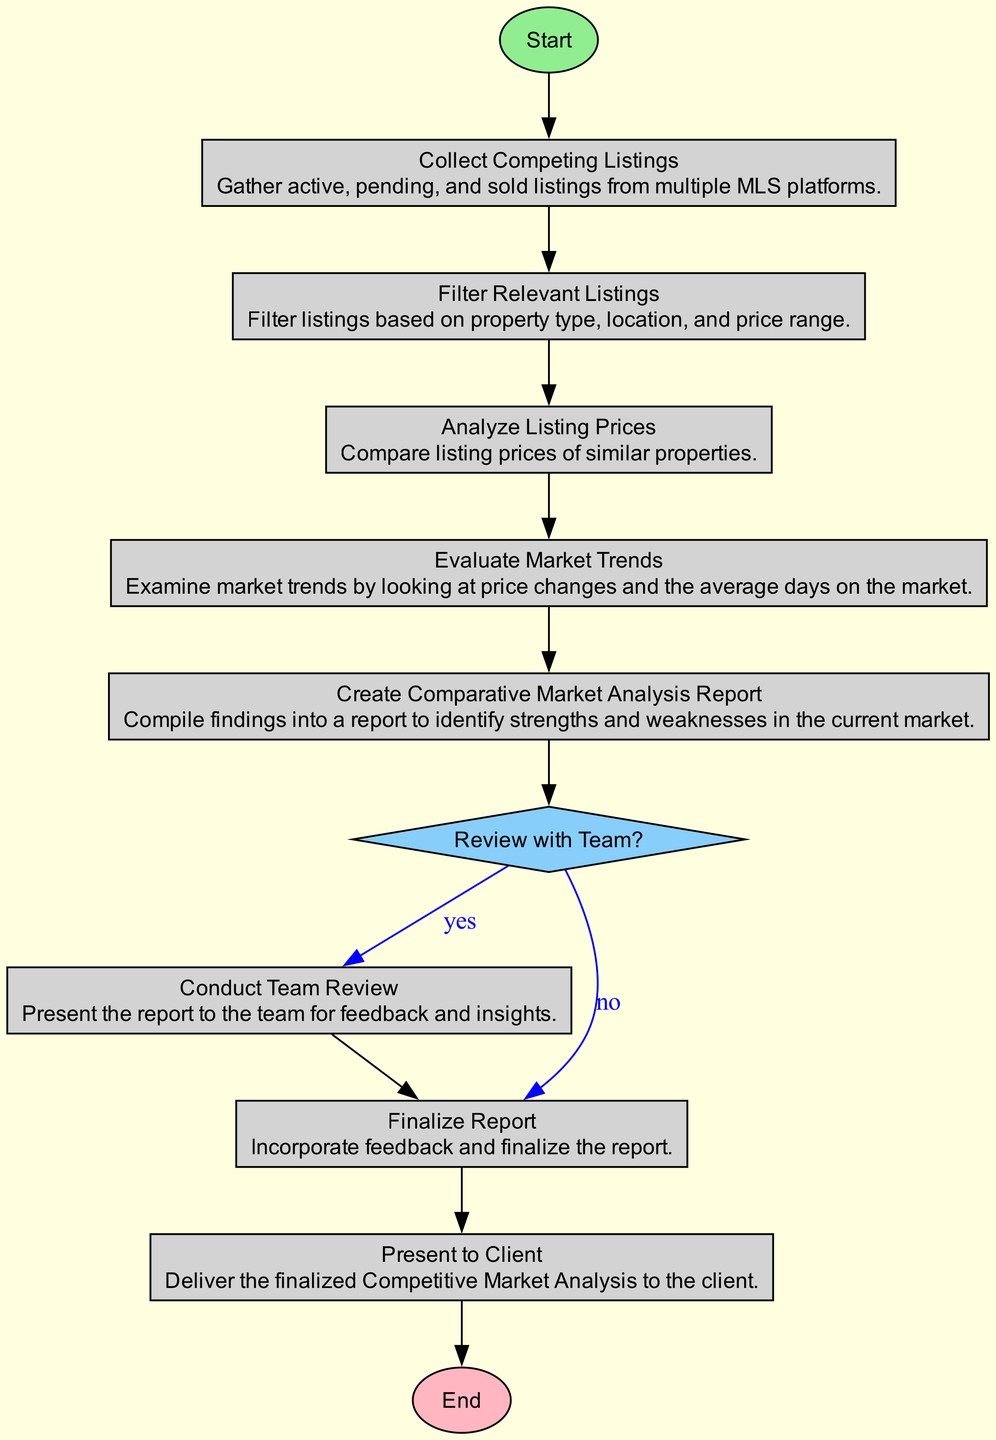What is the first step in the workflow? The first step in the workflow is represented by the "Start" node, which directs the process to "Collect Competing Listings."
Answer: Collect Competing Listings How many decision nodes are present in the diagram? By reviewing the diagram, there is one decision node labeled "Review with Team?" that leads to two possible outcomes.
Answer: 1 What comes after "Evaluate Market Trends"? After "Evaluate Market Trends," the workflow moves to "Create Comparative Market Analysis Report."
Answer: Create Comparative Market Analysis Report What happens if the answer is 'yes' to the decision node? If the answer is 'yes' to "Review with Team?", the process flows to "Conduct Team Review," where the report is presented for feedback.
Answer: Conduct Team Review Which process occurs before presenting the report to the client? Before presenting the report to the client, the process is "Finalize Report," where feedback is incorporated into the report.
Answer: Finalize Report What is the last step in the workflow? The last step in the workflow is represented by the "End" node, which indicates the completion of the process after presenting the report to the client.
Answer: End What is the outcome if the answer is 'no' to the decision node? If the answer is 'no' to "Review with Team?", the workflow directly proceeds to "Finalize Report," skipping the team review.
Answer: Finalize Report How many processes are present in the diagram? The diagram contains six process nodes: "Collect Competing Listings," "Filter Relevant Listings," "Analyze Listing Prices," "Evaluate Market Trends," "Create Comparative Market Analysis Report," and "Finalize Report."
Answer: 6 What is the overall purpose of this diagram? The overall purpose of this diagram is to illustrate the workflow for conducting a Competitive Market Analysis in real estate.
Answer: Competitive Market Analysis Workflow 